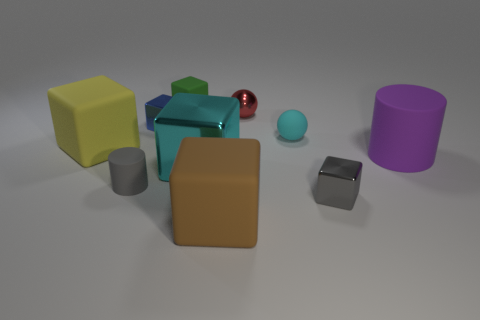Subtract all green rubber cubes. How many cubes are left? 5 Subtract all red spheres. How many spheres are left? 1 Subtract 2 balls. How many balls are left? 0 Add 6 small red matte cylinders. How many small red matte cylinders exist? 6 Subtract 1 cyan balls. How many objects are left? 9 Subtract all cubes. How many objects are left? 4 Subtract all purple balls. Subtract all yellow cylinders. How many balls are left? 2 Subtract all blue cylinders. How many cyan cubes are left? 1 Subtract all small rubber objects. Subtract all yellow balls. How many objects are left? 7 Add 1 blue metal cubes. How many blue metal cubes are left? 2 